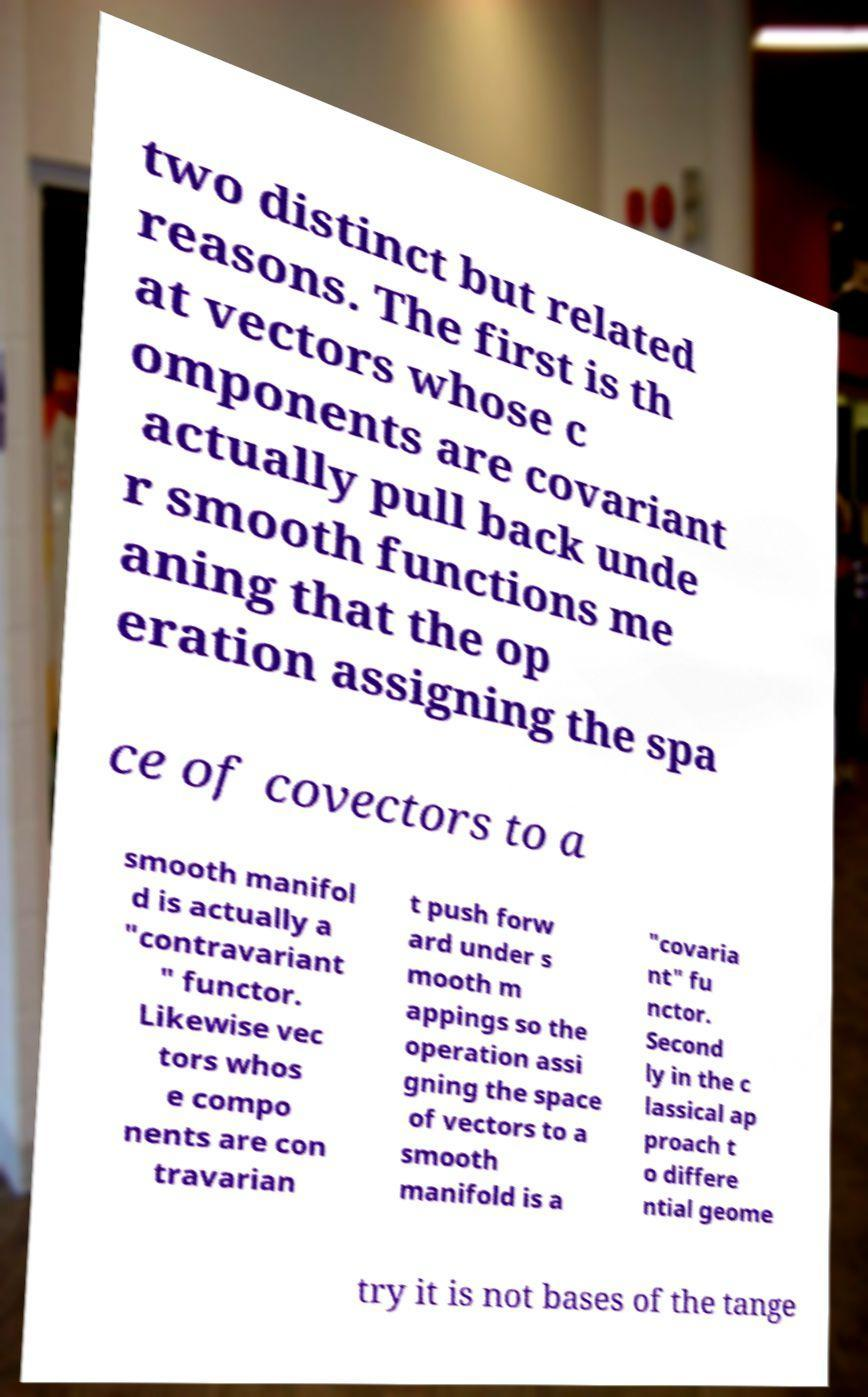I need the written content from this picture converted into text. Can you do that? two distinct but related reasons. The first is th at vectors whose c omponents are covariant actually pull back unde r smooth functions me aning that the op eration assigning the spa ce of covectors to a smooth manifol d is actually a "contravariant " functor. Likewise vec tors whos e compo nents are con travarian t push forw ard under s mooth m appings so the operation assi gning the space of vectors to a smooth manifold is a "covaria nt" fu nctor. Second ly in the c lassical ap proach t o differe ntial geome try it is not bases of the tange 